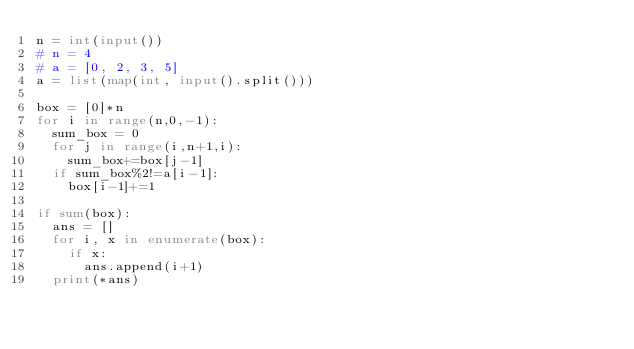Convert code to text. <code><loc_0><loc_0><loc_500><loc_500><_Python_>n = int(input())
# n = 4
# a = [0, 2, 3, 5]
a = list(map(int, input().split()))

box = [0]*n
for i in range(n,0,-1):
	sum_box = 0
	for j in range(i,n+1,i):
		sum_box+=box[j-1]
	if sum_box%2!=a[i-1]:
		box[i-1]+=1

if sum(box):
	ans = []
	for i, x in enumerate(box):
		if x:
			ans.append(i+1)
	print(*ans)</code> 